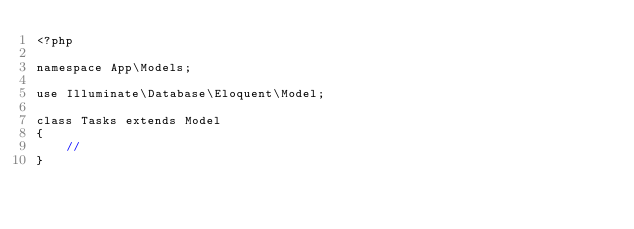<code> <loc_0><loc_0><loc_500><loc_500><_PHP_><?php

namespace App\Models;

use Illuminate\Database\Eloquent\Model;

class Tasks extends Model
{
    //
}
</code> 